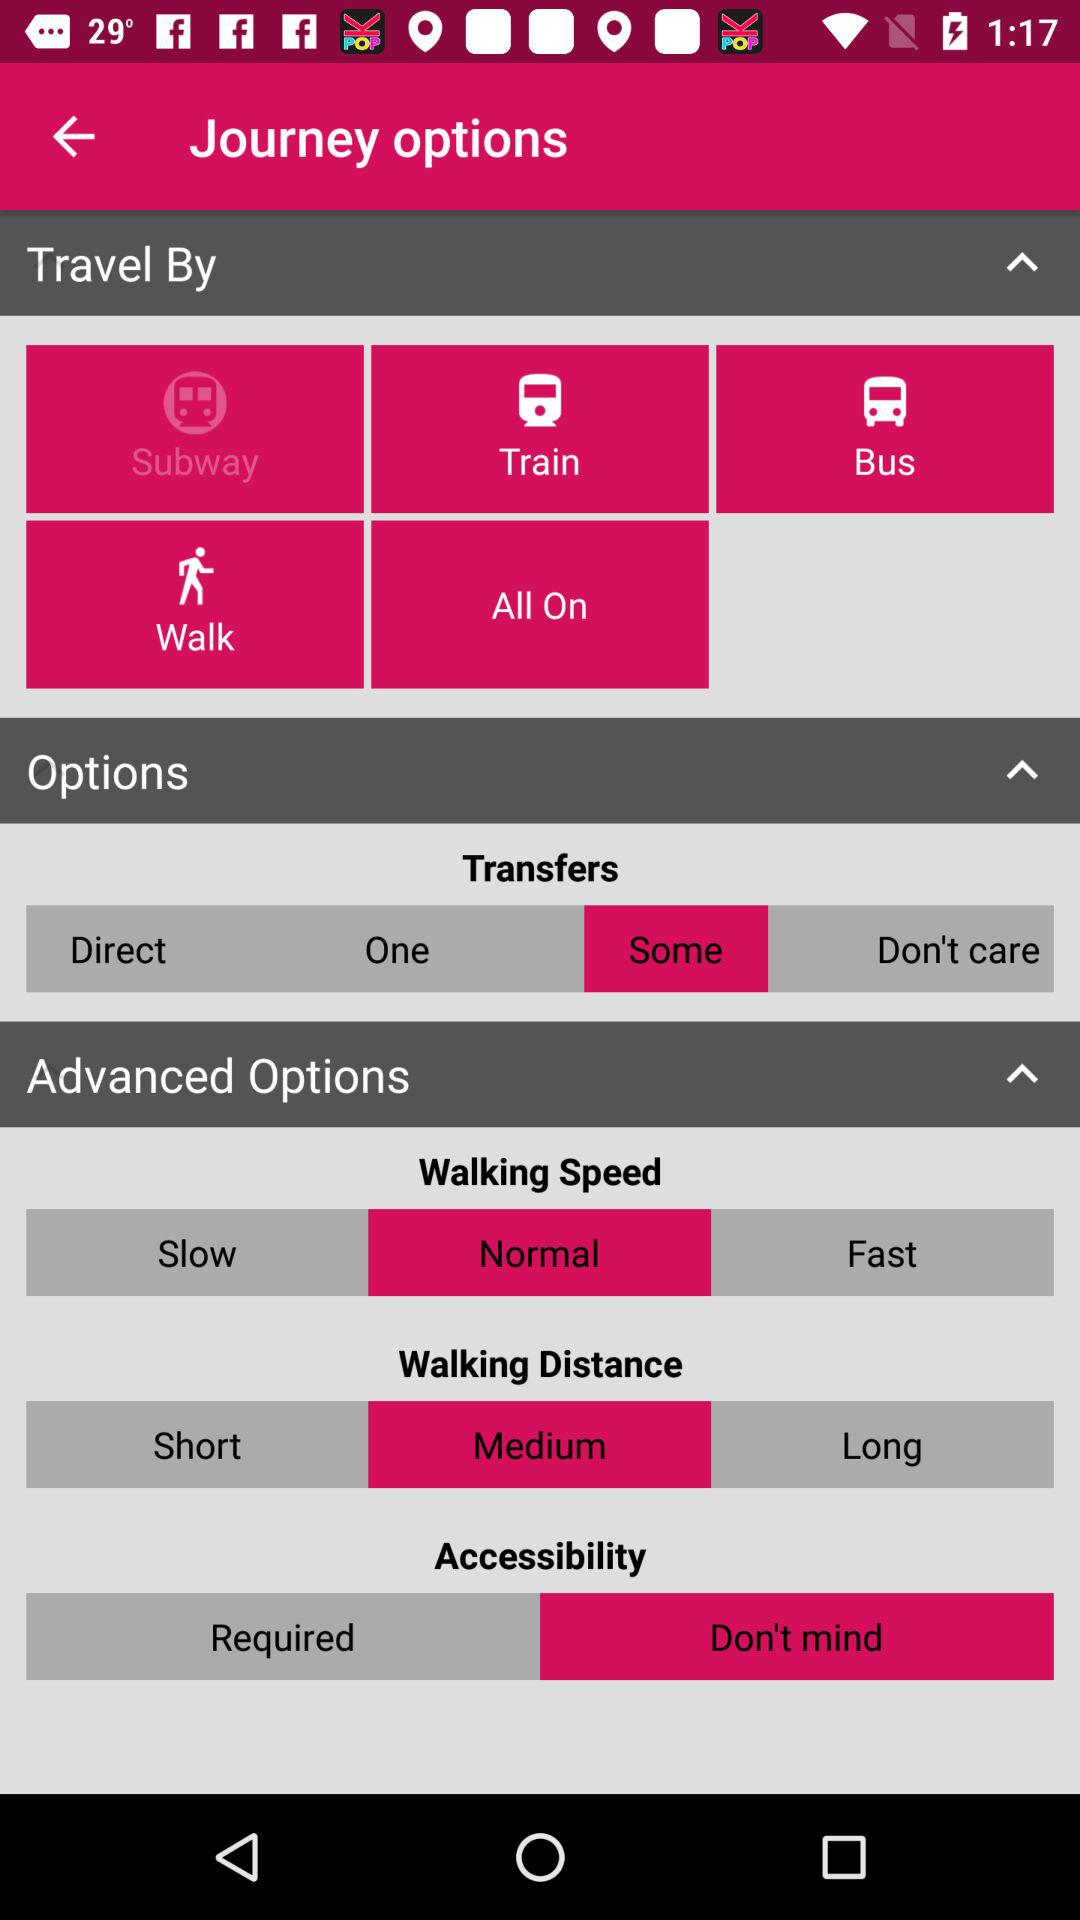What is the selected option for accessibility? The selected option is "Don't mind". 